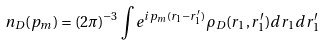<formula> <loc_0><loc_0><loc_500><loc_500>n _ { D } ( { p } _ { m } ) = { ( 2 \pi ) ^ { - 3 } } \int e ^ { i { p } _ { m } ( { r } _ { 1 } - { r } _ { 1 } ^ { \prime } ) } \rho _ { D } ( { r } _ { 1 } , { r } _ { 1 } ^ { \prime } ) d { r } _ { 1 } d { r } _ { 1 } ^ { \prime }</formula> 